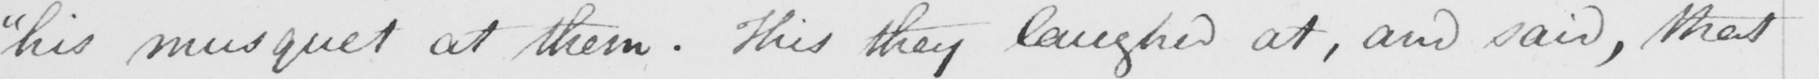What does this handwritten line say? " his musquet at them . This they laughed at , and said , that 